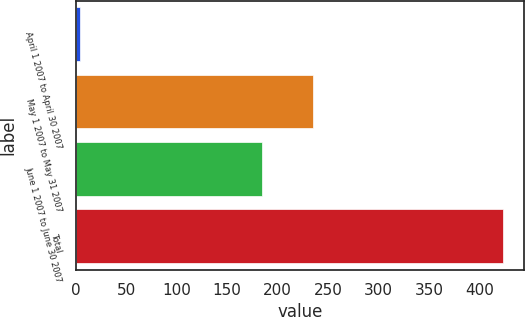Convert chart to OTSL. <chart><loc_0><loc_0><loc_500><loc_500><bar_chart><fcel>April 1 2007 to April 30 2007<fcel>May 1 2007 to May 31 2007<fcel>June 1 2007 to June 30 2007<fcel>Total<nl><fcel>4<fcel>235<fcel>184<fcel>423<nl></chart> 